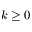<formula> <loc_0><loc_0><loc_500><loc_500>k \geq 0</formula> 